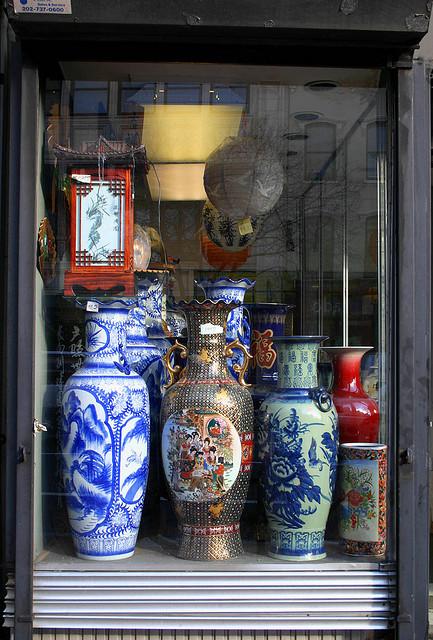How many windows do you see?
Be succinct. 1. Is this asian art?
Keep it brief. Yes. Are all these bases the same color?
Short answer required. No. 